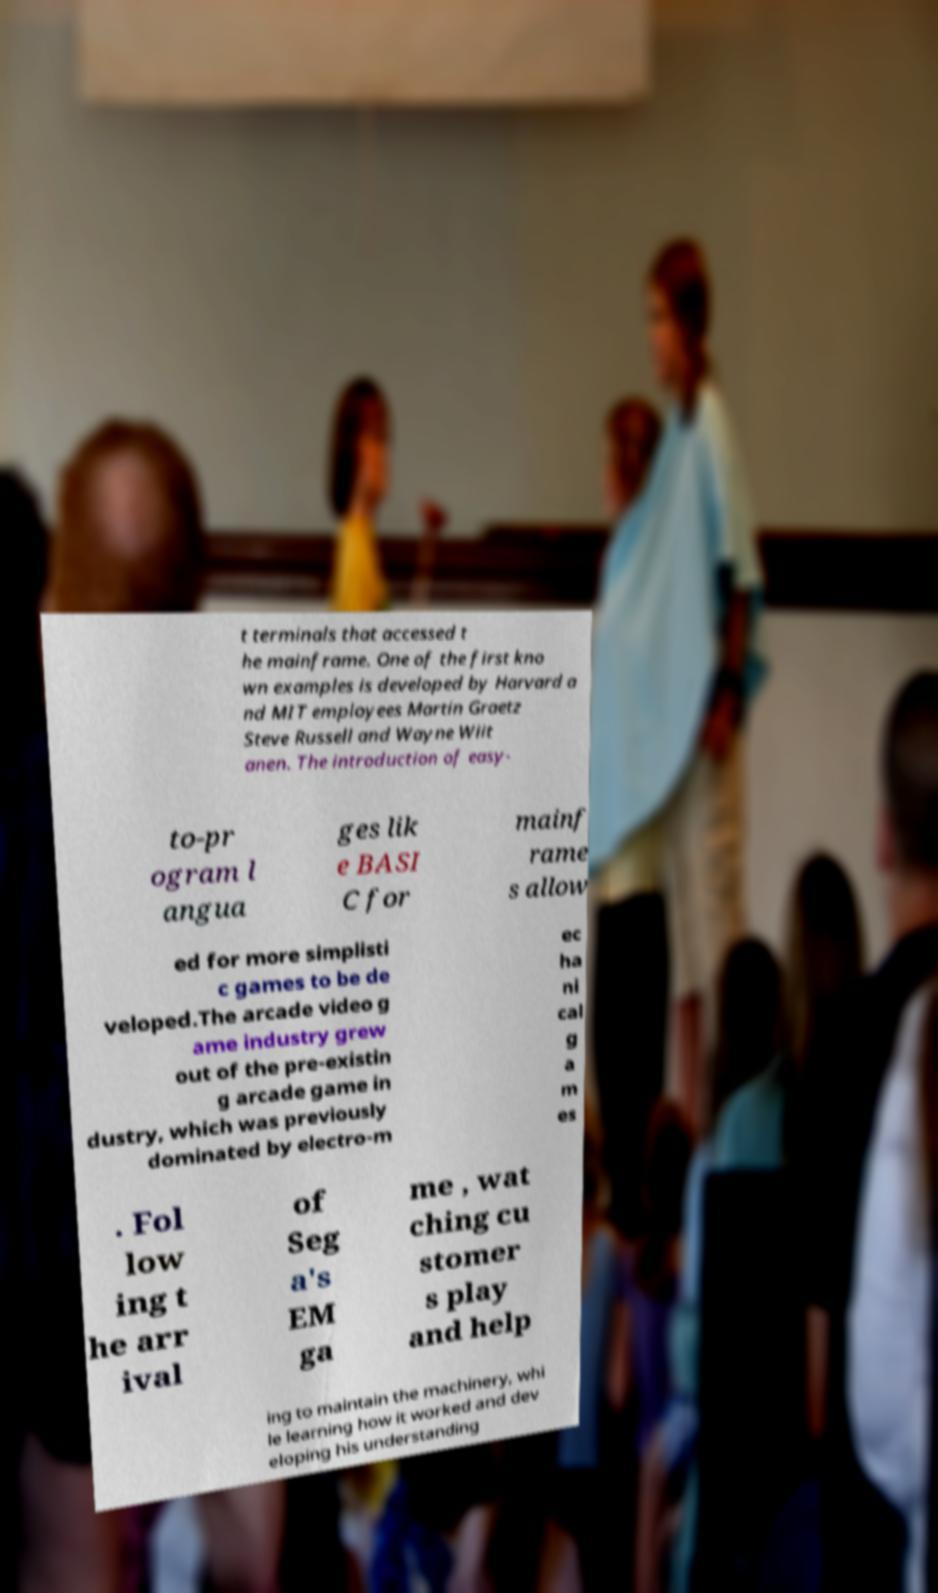There's text embedded in this image that I need extracted. Can you transcribe it verbatim? t terminals that accessed t he mainframe. One of the first kno wn examples is developed by Harvard a nd MIT employees Martin Graetz Steve Russell and Wayne Wiit anen. The introduction of easy- to-pr ogram l angua ges lik e BASI C for mainf rame s allow ed for more simplisti c games to be de veloped.The arcade video g ame industry grew out of the pre-existin g arcade game in dustry, which was previously dominated by electro-m ec ha ni cal g a m es . Fol low ing t he arr ival of Seg a's EM ga me , wat ching cu stomer s play and help ing to maintain the machinery, whi le learning how it worked and dev eloping his understanding 